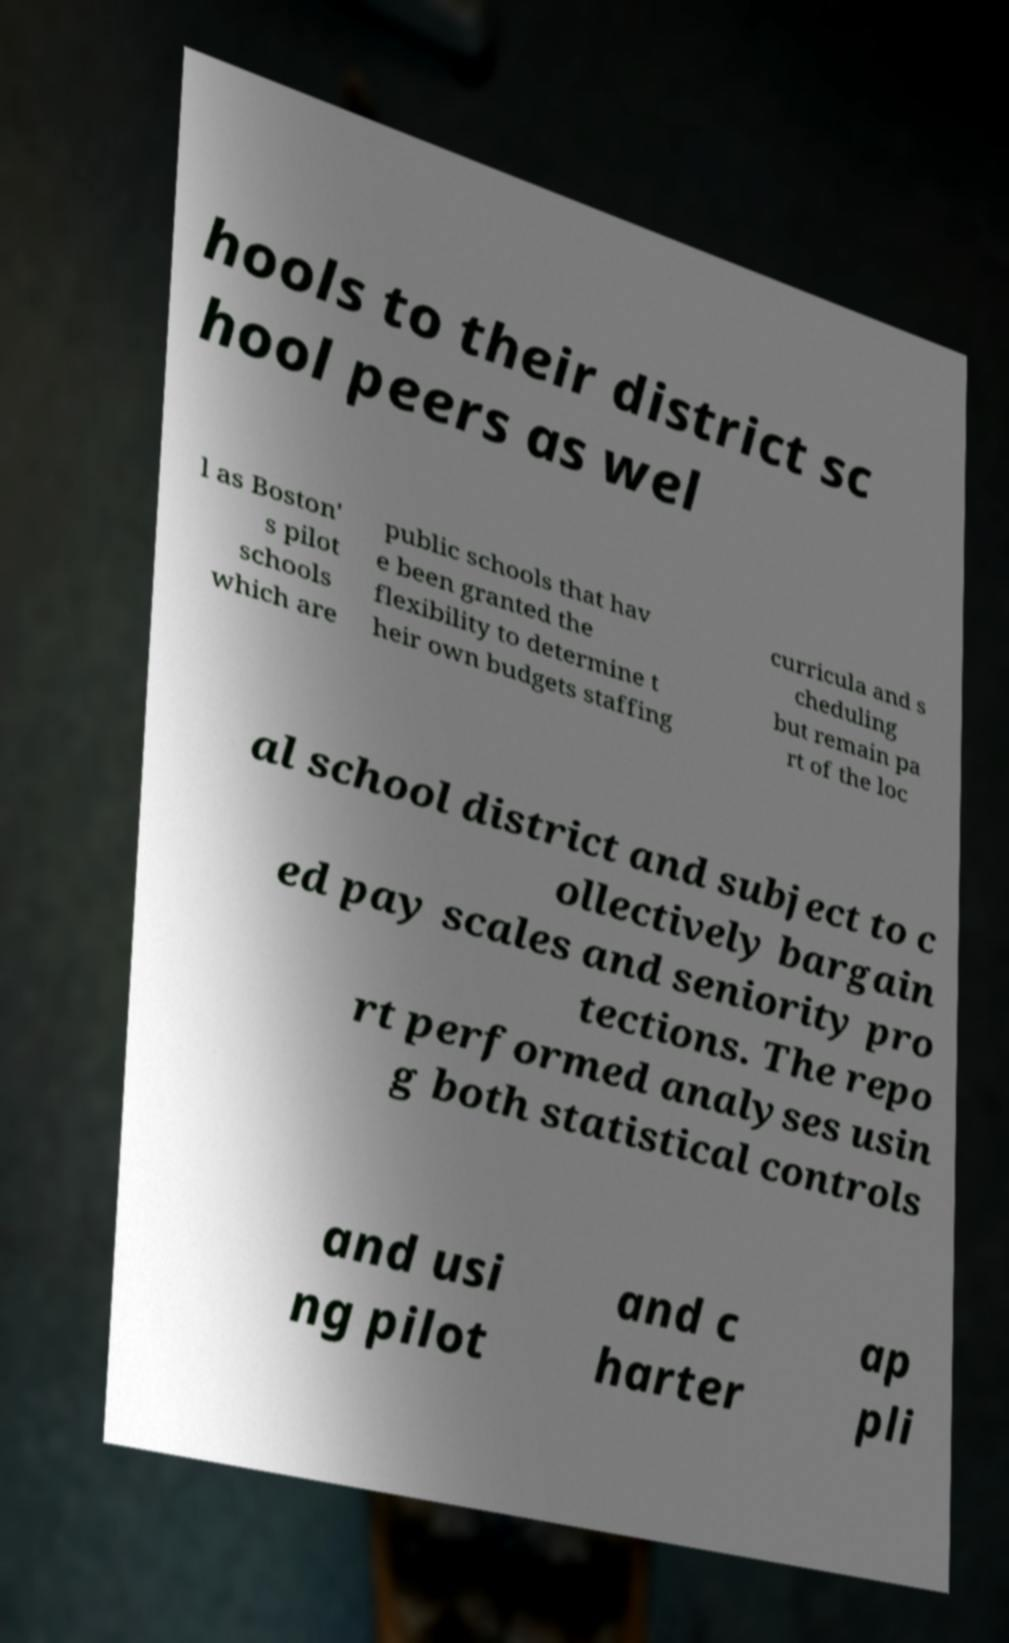Please identify and transcribe the text found in this image. hools to their district sc hool peers as wel l as Boston' s pilot schools which are public schools that hav e been granted the flexibility to determine t heir own budgets staffing curricula and s cheduling but remain pa rt of the loc al school district and subject to c ollectively bargain ed pay scales and seniority pro tections. The repo rt performed analyses usin g both statistical controls and usi ng pilot and c harter ap pli 